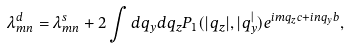Convert formula to latex. <formula><loc_0><loc_0><loc_500><loc_500>\lambda ^ { d } _ { m n } = \lambda ^ { s } _ { m n } + 2 \int d q _ { y } d q _ { z } P _ { 1 } ( | q _ { z } | , | q _ { y } ^ { | } ) e ^ { i m q _ { z } c + i n q _ { y } b } ,</formula> 